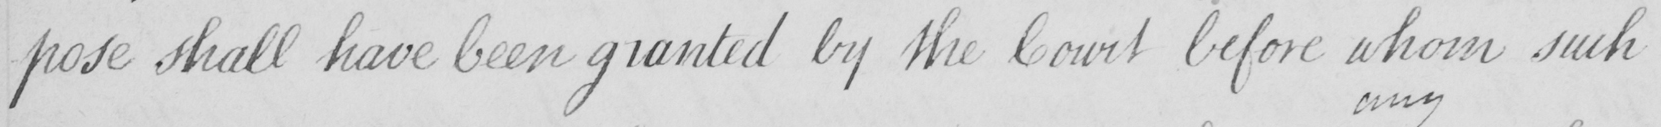Can you tell me what this handwritten text says? -pose  shall have been granted by the Court before whom such 